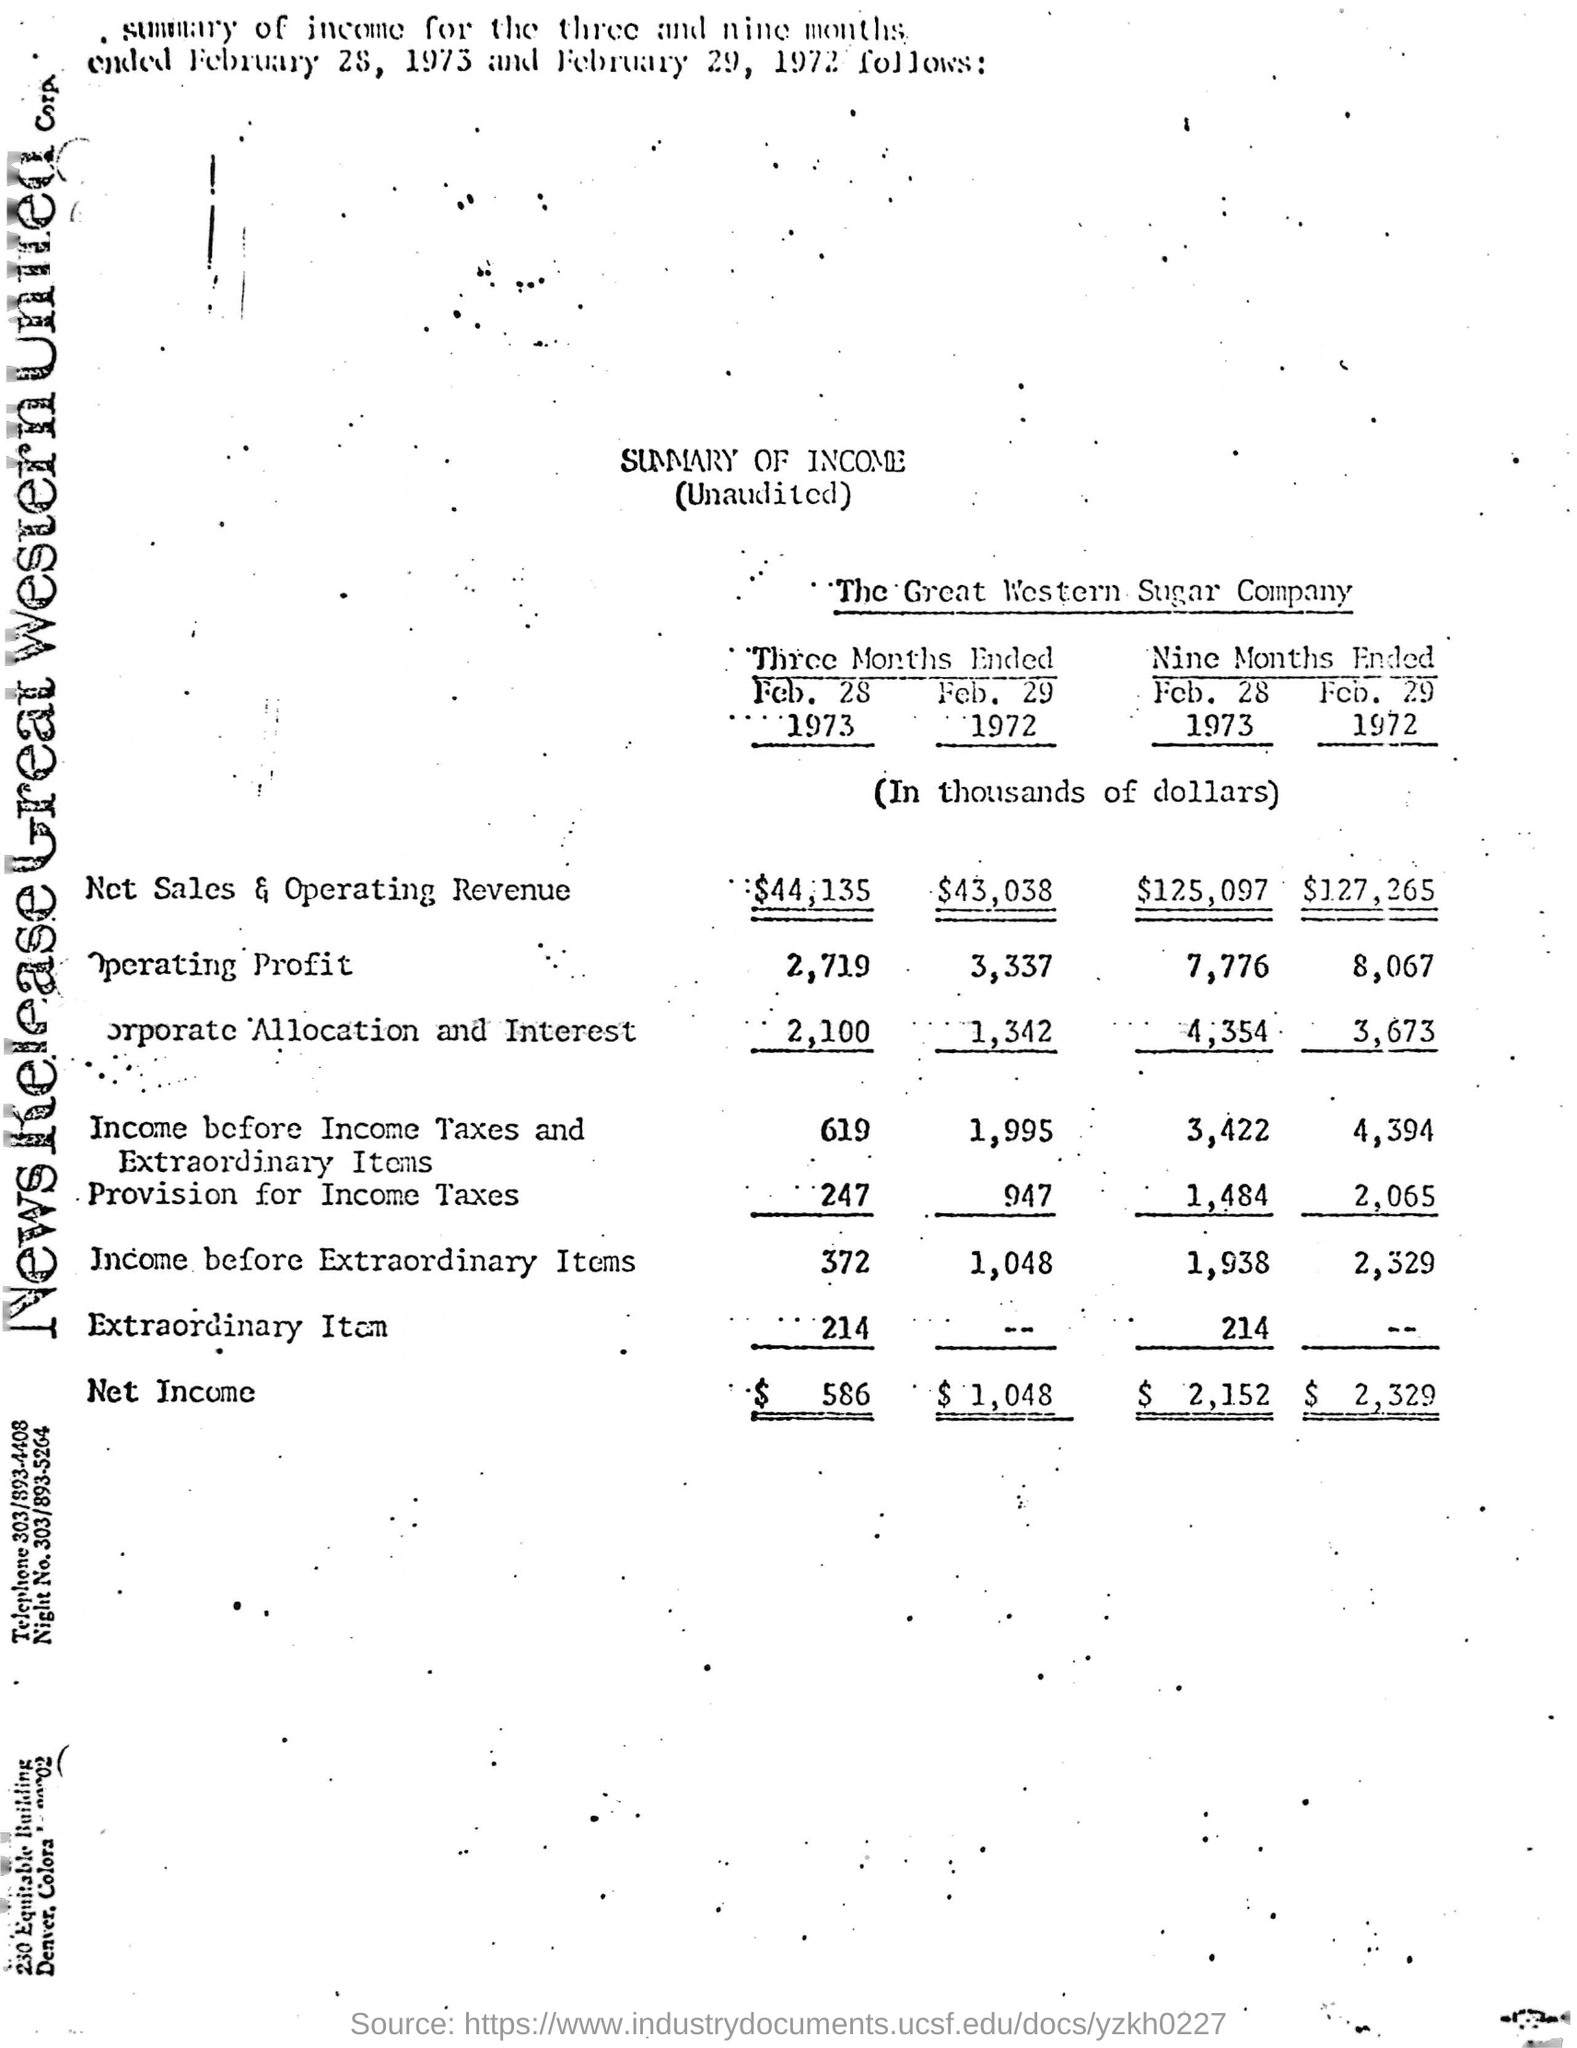Indicate a few pertinent items in this graphic. The amounts and figures provided were in a specific currency, namely dollars. The name of the company is The Great Western Sugar Company. 